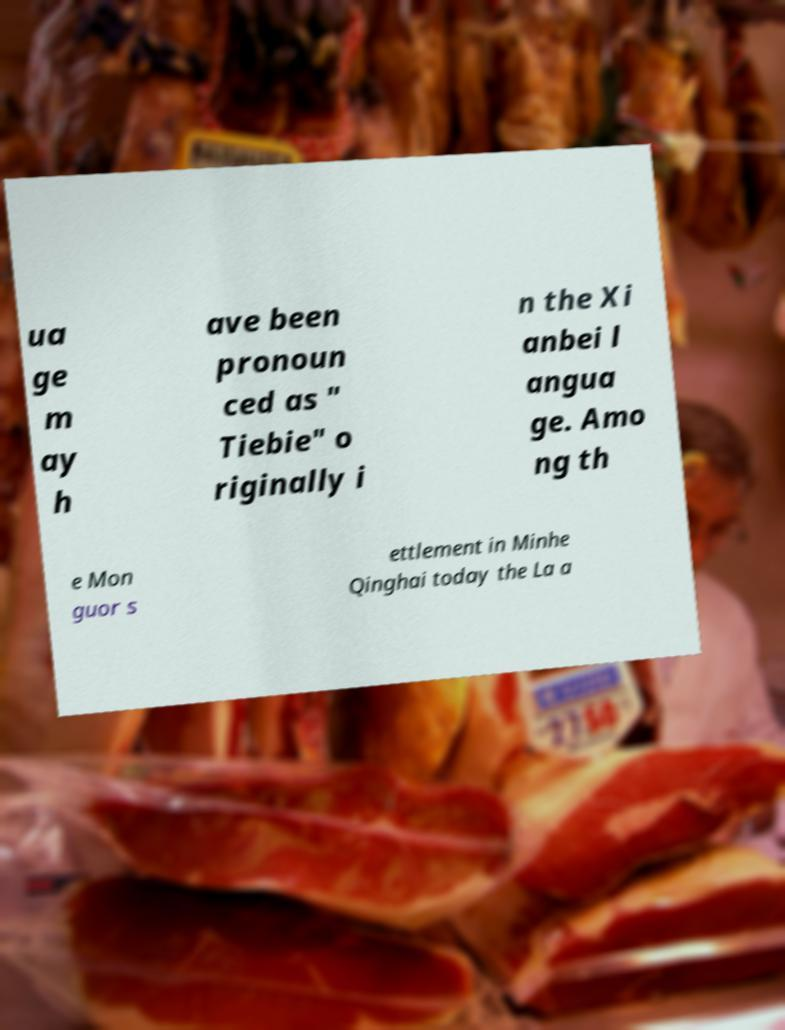What messages or text are displayed in this image? I need them in a readable, typed format. ua ge m ay h ave been pronoun ced as " Tiebie" o riginally i n the Xi anbei l angua ge. Amo ng th e Mon guor s ettlement in Minhe Qinghai today the La a 